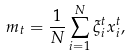<formula> <loc_0><loc_0><loc_500><loc_500>m _ { t } = \frac { 1 } { N } \sum _ { i = 1 } ^ { N } \xi _ { i } ^ { t } x _ { i } ^ { t } ,</formula> 